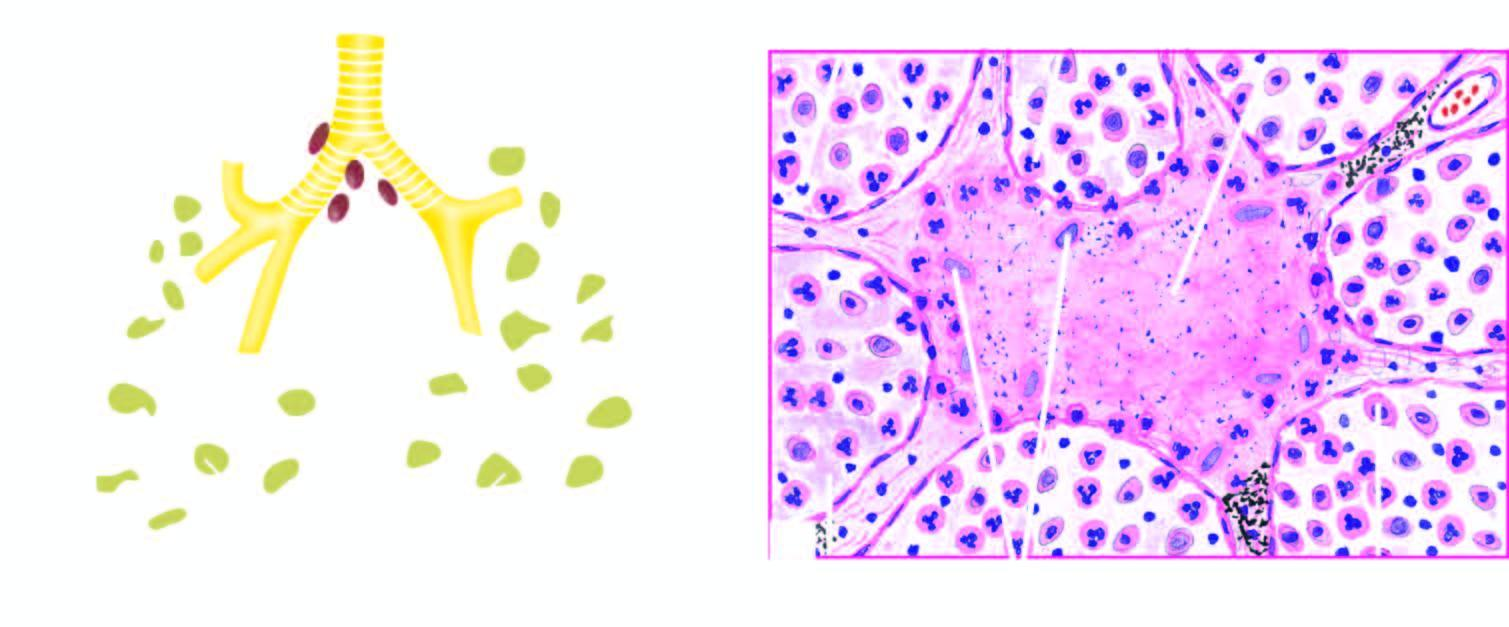do apoptosis have numerous acid-fast bacilli not shown here in afb staining?
Answer the question using a single word or phrase. No 